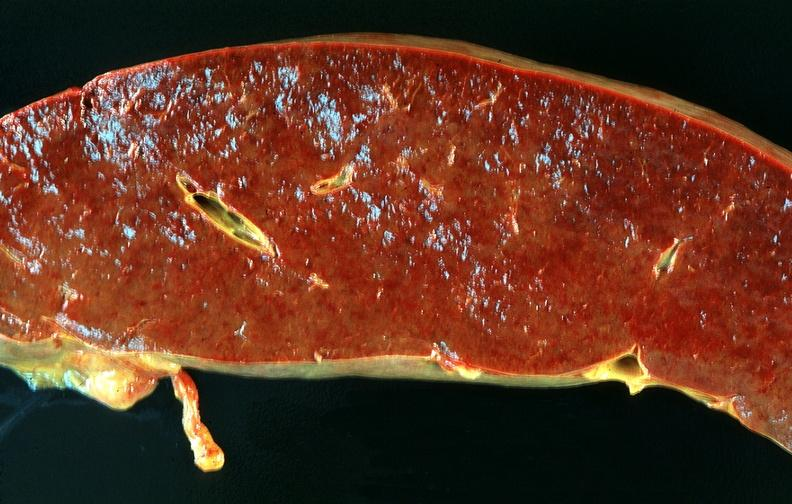what does this image show?
Answer the question using a single word or phrase. Spleen 